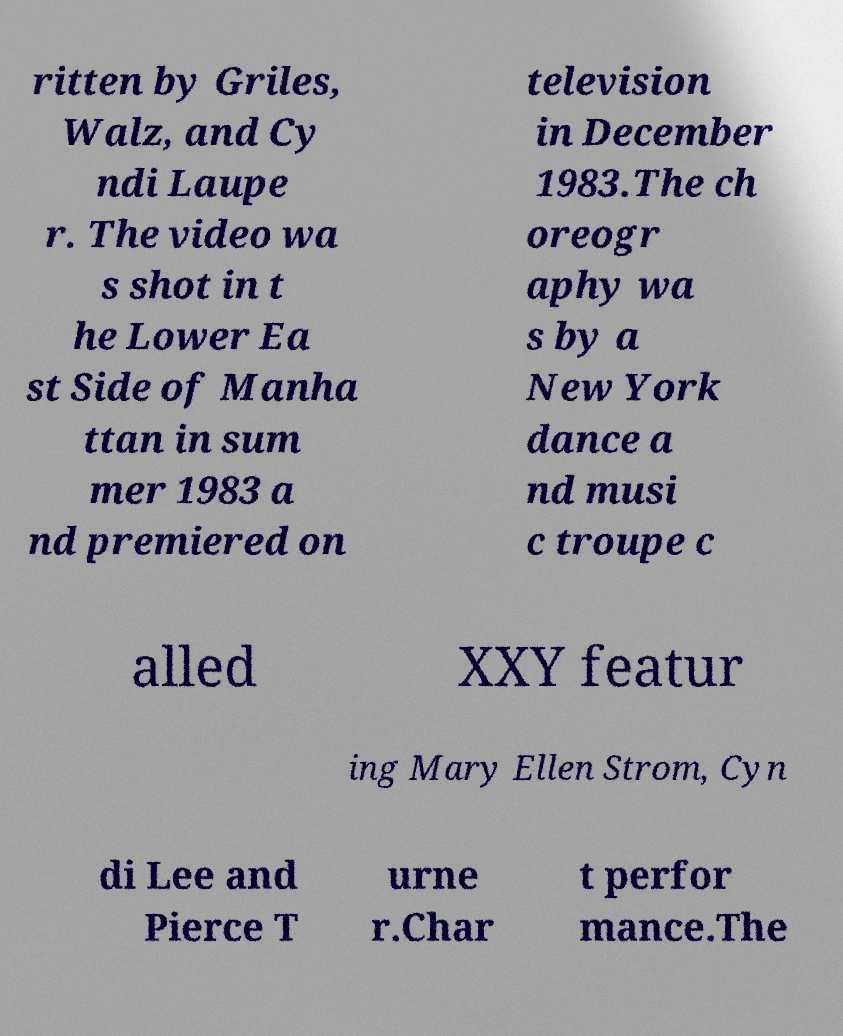Can you accurately transcribe the text from the provided image for me? ritten by Griles, Walz, and Cy ndi Laupe r. The video wa s shot in t he Lower Ea st Side of Manha ttan in sum mer 1983 a nd premiered on television in December 1983.The ch oreogr aphy wa s by a New York dance a nd musi c troupe c alled XXY featur ing Mary Ellen Strom, Cyn di Lee and Pierce T urne r.Char t perfor mance.The 